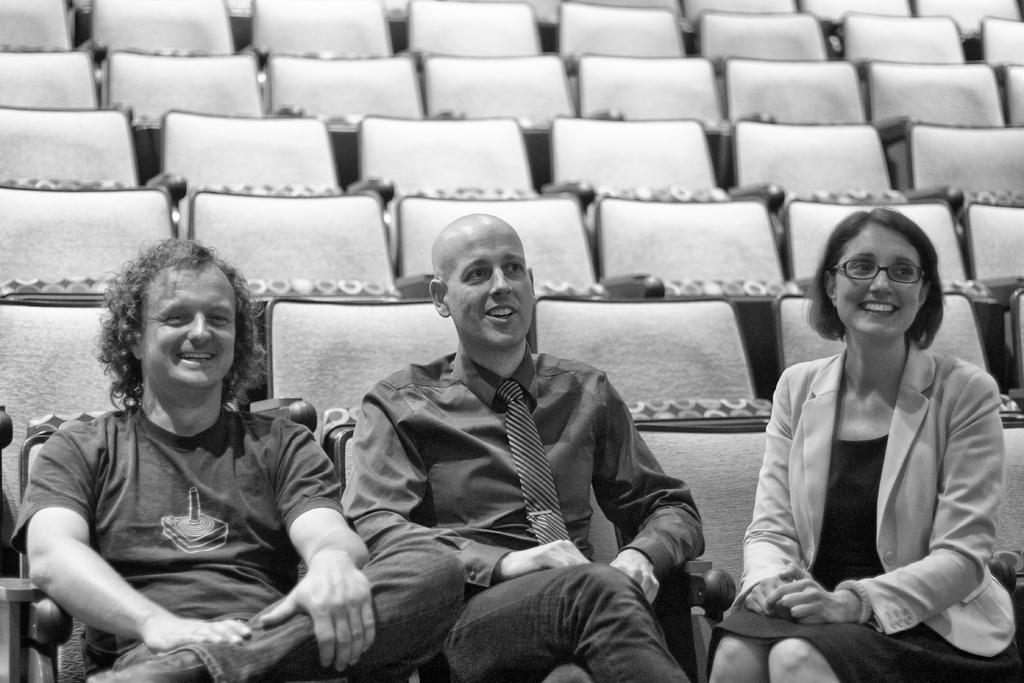What are the people in the image doing? The people in the image are sitting on chairs. Where are the chairs located in the image? The chairs are located at the bottom side of the image. Are there any chairs visible in other parts of the image? Yes, there are chairs visible at the top side of the image. How does the boy interact with the calendar in the image? There is no boy or calendar present in the image. What is the attention span of the people sitting on chairs in the image? The provided facts do not give information about the attention span of the people sitting on chairs in the image. 